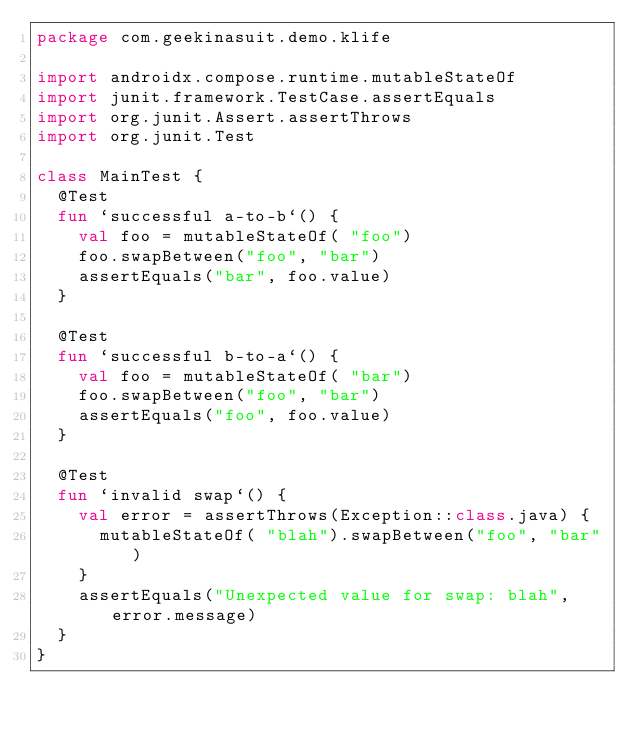<code> <loc_0><loc_0><loc_500><loc_500><_Kotlin_>package com.geekinasuit.demo.klife

import androidx.compose.runtime.mutableStateOf
import junit.framework.TestCase.assertEquals
import org.junit.Assert.assertThrows
import org.junit.Test

class MainTest {
  @Test
  fun `successful a-to-b`() {
    val foo = mutableStateOf( "foo")
    foo.swapBetween("foo", "bar")
    assertEquals("bar", foo.value)
  }

  @Test
  fun `successful b-to-a`() {
    val foo = mutableStateOf( "bar")
    foo.swapBetween("foo", "bar")
    assertEquals("foo", foo.value)
  }

  @Test
  fun `invalid swap`() {
    val error = assertThrows(Exception::class.java) {
      mutableStateOf( "blah").swapBetween("foo", "bar")
    }
    assertEquals("Unexpected value for swap: blah", error.message)
  }
}
</code> 